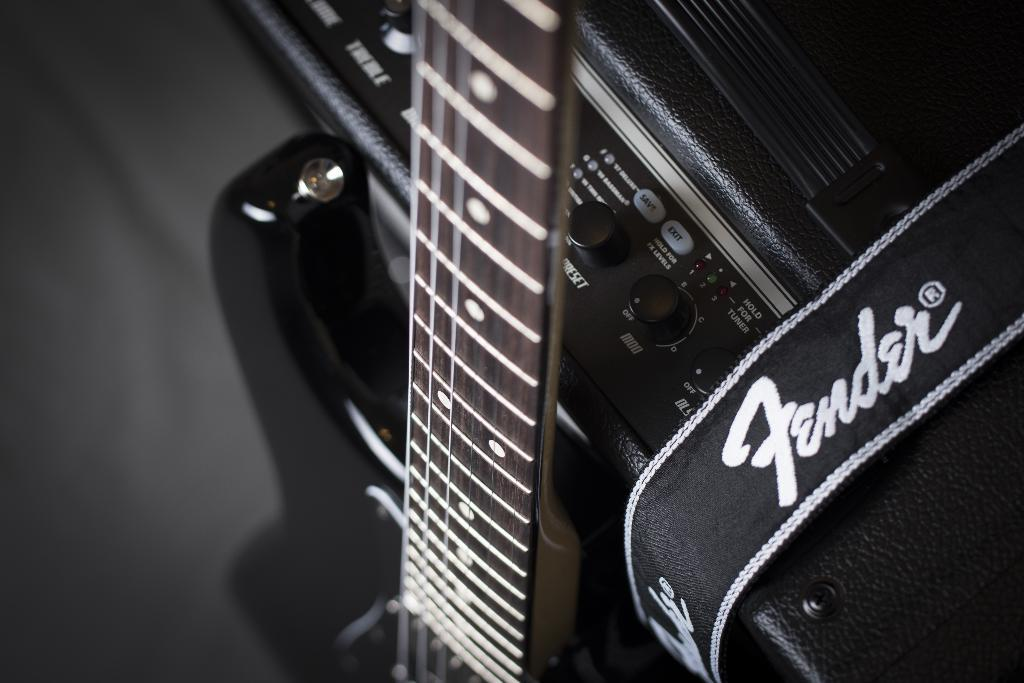What type of object is the musical instrument in the image? The specific type of musical instrument is not mentioned, but it is present in the image. Can you describe the machine in the image? The details of the machine are not provided, but it is mentioned as being in the image. What date is circled on the calendar in the image? There is no calendar present in the image, so it is not possible to answer that question. 